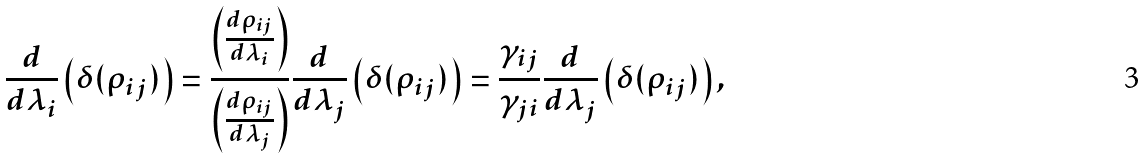<formula> <loc_0><loc_0><loc_500><loc_500>\frac { d } { d \lambda _ { i } } \left ( \delta ( \rho _ { i j } ) \right ) = \frac { \left ( \frac { d \rho _ { i j } } { d \lambda _ { i } } \right ) } { \left ( \frac { d \rho _ { i j } } { d \lambda _ { j } } \right ) } \frac { d } { d \lambda _ { j } } \left ( \delta ( \rho _ { i j } ) \right ) = \frac { \gamma _ { i j } } { \gamma _ { j i } } \frac { d } { d \lambda _ { j } } \left ( \delta ( \rho _ { i j } ) \right ) ,</formula> 